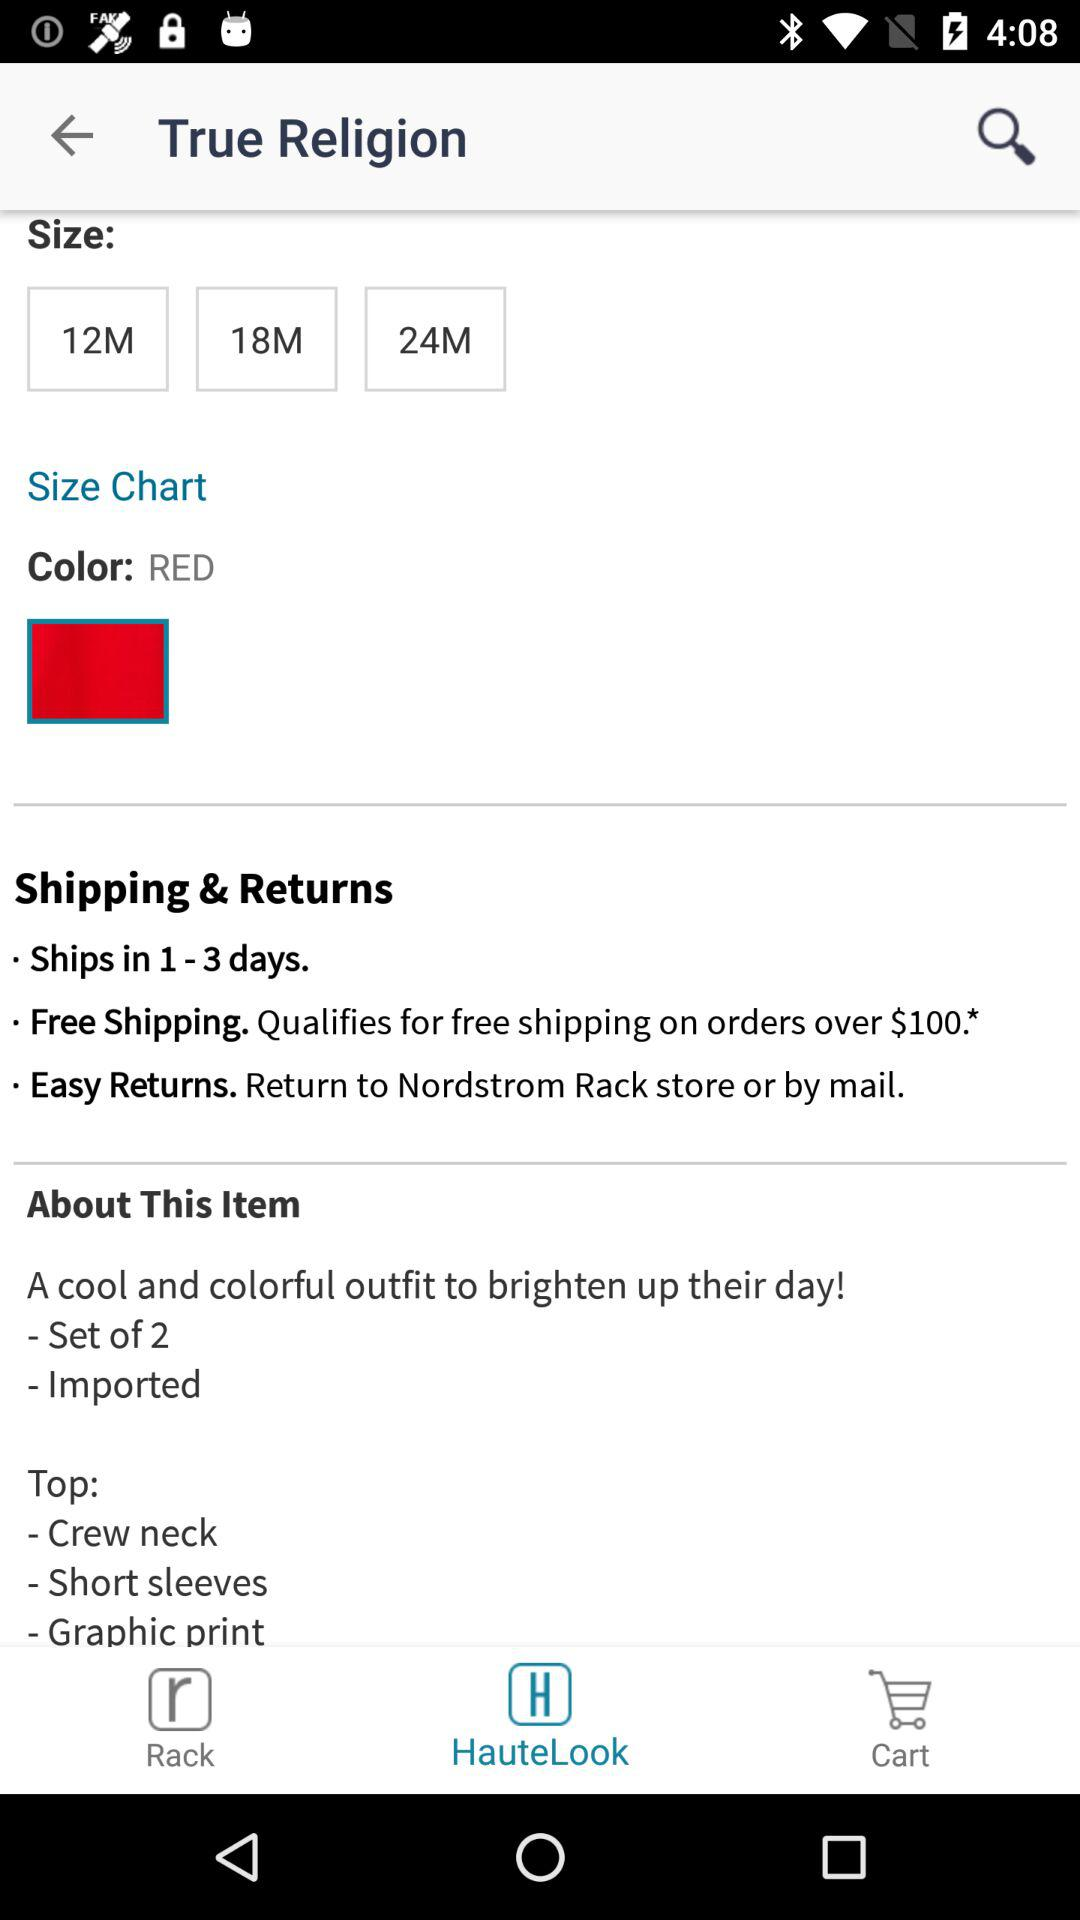What is the easy way to return the product? You can return the product to the Nordstrom Rack store or by mail. 